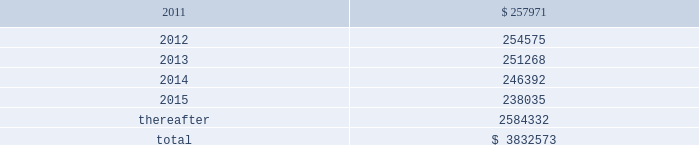American tower corporation and subsidiaries notes to consolidated financial statements mexico litigation 2014one of the company 2019s subsidiaries , spectrasite communications , inc .
( 201csci 201d ) , is involved in a lawsuit brought in mexico against a former mexican subsidiary of sci ( the subsidiary of sci was sold in 2002 , prior to the company 2019s merger with sci 2019s parent in 2005 ) .
The lawsuit concerns a terminated tower construction contract and related agreements with a wireless carrier in mexico .
The primary issue for the company is whether sci itself can be found liable to the mexican carrier .
The trial and lower appellate courts initially found that sci had no such liability in part because mexican courts do not have the necessary jurisdiction over sci .
Following several decisions by mexican appellate courts , including the supreme court of mexico , and related appeals by both parties , an intermediate appellate court issued a new decision that would , if enforceable , reimpose liability on sci in september 2010 .
In its decision , the intermediate appellate court identified potential damages of approximately $ 6.7 million , and on october 14 , 2010 , the company filed a new constitutional appeal to again dispute the decision .
As a result , at this stage of the proceeding , the company is unable to determine whether the liability imposed on sci by the september 2010 decision will survive or to estimate its share , if any , of that potential liability if the decision survives the pending appeal .
Xcel litigation 2014on june 3 , 2010 , horse-shoe capital ( 201chorse-shoe 201d ) , a company formed under the laws of the republic of mauritius , filed a complaint in the supreme court of the state of new york , new york county , with respect to horse-shoe 2019s sale of xcel to american tower mauritius ( 201catmauritius 201d ) , the company 2019s wholly-owned subsidiary formed under the laws of the republic of mauritius .
The complaint names atmauritius , ati and the company as defendants , and the dispute concerns the timing and amount of distributions to be made by atmauritius to horse-shoe from a $ 7.5 million holdback escrow account and a $ 15.7 million tax escrow account , each established by the transaction agreements at closing .
The complaint seeks release of the entire holdback escrow account , plus an additional $ 2.8 million , as well as the release of approximately $ 12.0 million of the tax escrow account .
The complaint also seeks punitive damages in excess of $ 69.0 million .
The company filed an answer to the complaint in august 2010 , disputing both the amounts alleged to be owed under the escrow agreements as well as the timing of the escrow distributions .
The company also asserted in its answer that the demand for punitive damages is meritless .
The parties have filed cross-motions for summary judgment concerning the release of the tax escrow account and in january 2011 the court granted the company 2019s motion for summary judgment , finding no obligation for the company to release the disputed portion of the tax escrow until 2013 .
Other claims are pending .
The company is vigorously defending the lawsuit .
Lease obligations 2014the company leases certain land , office and tower space under operating leases that expire over various terms .
Many of the leases contain renewal options with specified increases in lease payments upon exercise of the renewal option .
Escalation clauses present in operating leases , excluding those tied to cpi or other inflation-based indices , are recognized on a straight-line basis over the non-cancellable term of the lease .
Future minimum rental payments under non-cancellable operating leases include payments for certain renewal periods at the company 2019s option because failure to renew could result in a loss of the applicable tower site and related revenues from tenant leases , thereby making it reasonably assured that the company will renew the lease .
Such payments in effect at december 31 , 2010 are as follows ( in thousands ) : year ending december 31 .

What portion of the total future minimum rental payments is due in the next 24 months? 
Computations: ((257971 + 254575) / 3832573)
Answer: 0.13373. 